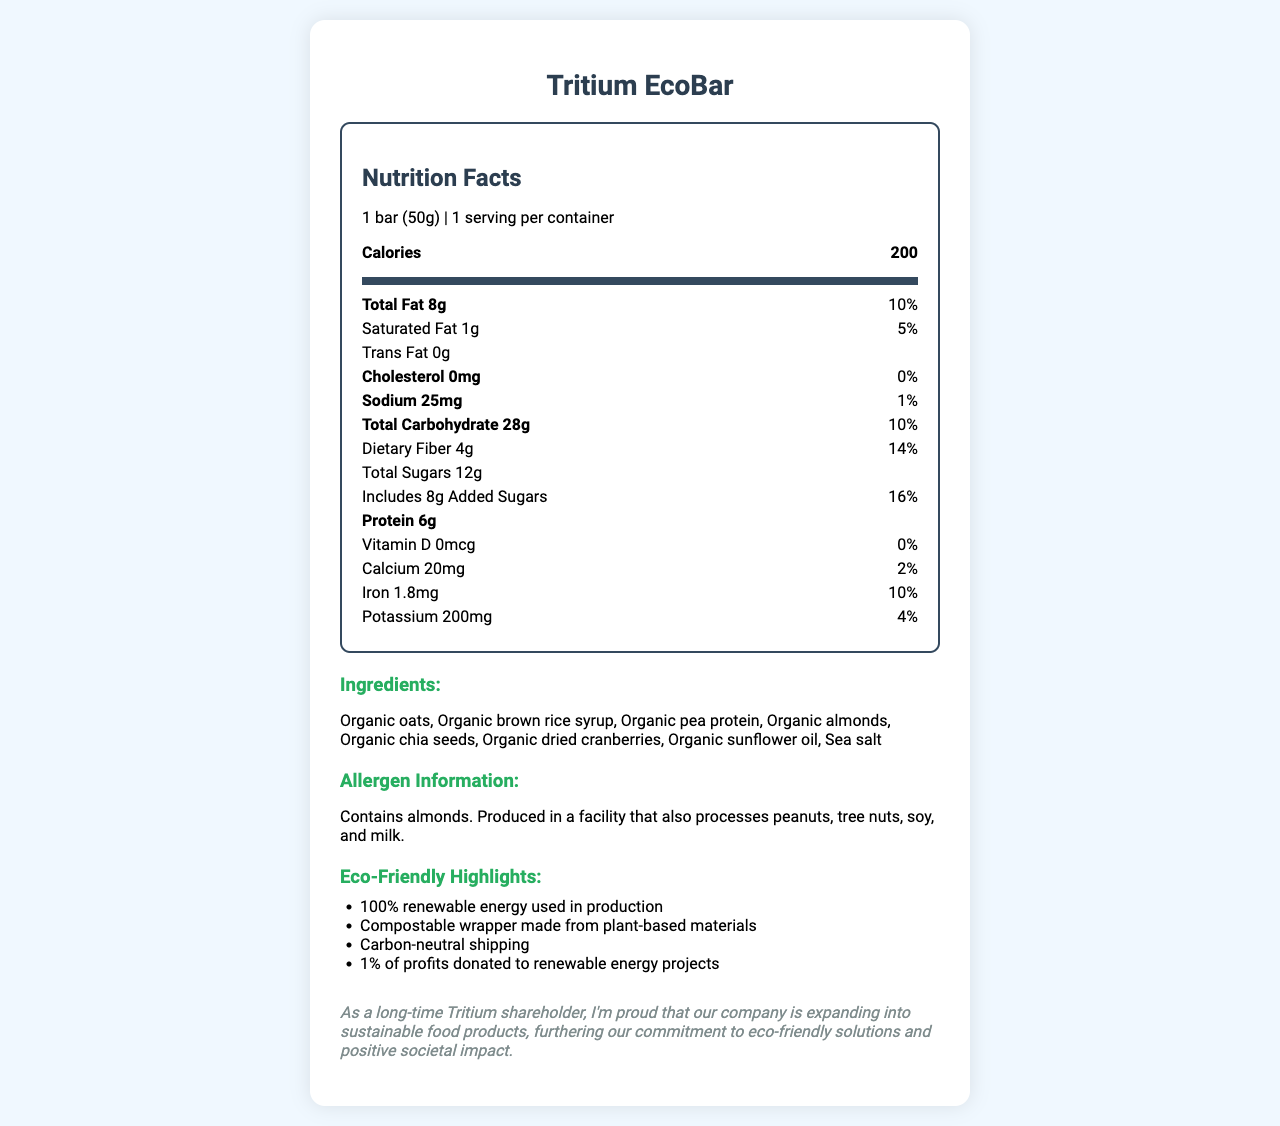what is the serving size? The serving size is mentioned near the top of the nutrition facts: "1 bar (50g)."
Answer: 1 bar (50g) how much dietary fiber does a Tritium EcoBar contain? The amount of dietary fiber is listed under "Total Carbohydrate": "Dietary Fiber 4g."
Answer: 4g how many calories are in one Tritium EcoBar? The number of calories is prominently displayed under "Calories": "200."
Answer: 200 which ingredient is not organic? The list of ingredients includes many organic items, but "Sea salt" does not have the "organic" label.
Answer: Sea salt what percentage of the daily value for iron does one bar provide? Under the iron nutrient information, it states: "Iron 1.8mg 10%."
Answer: 10% what are the eco-friendly highlights associated with the Tritium EcoBar? These points are all listed under the "Eco-Friendly Highlights" section of the document.
Answer: 100% renewable energy used in production, Compostable wrapper made from plant-based materials, Carbon-neutral shipping, 1% of profits donated to renewable energy projects how much protein is in a Tritium EcoBar? The amount of protein is listed in the nutrition facts: "Protein 6g."
Answer: 6g does a Tritium EcoBar contain any trans fat? The document specifically states "Trans Fat 0g."
Answer: No what allergens is the Tritium EcoBar produced near? A. Peanuts B. Tree nuts C. Soy D. Milk E. All of the above The allergen information notes that it is produced in a facility that processes: "peanuts, tree nuts, soy, and milk."
Answer: E how much added sugar is in one bar? A. 4g B. 8g C. 10g D. 12g Under sugars, it states: "Includes 8g Added Sugars."
Answer: B is the wrapper of the Tritium EcoBar compostable? The eco-friendly highlights include "Compostable wrapper made from plant-based materials."
Answer: Yes how is Tritium contributing to renewable energy projects? This is stated in the eco-friendly highlights: "1% of profits donated to renewable energy projects."
Answer: 1% of profits donated to renewable energy projects what is the main message of the document? The document includes the nutrition facts, a list of ingredients, allergen information, eco-friendly highlights, and a shareholder note emphasizing Tritium's commitment to positive societal impact through sustainable food products.
Answer: The main message of the document is to provide detailed nutritional information about the Tritium EcoBar, highlighting its eco-friendly attributes and the company's dedication to sustainable practices. what is the source of pea protein? The document lists "Organic pea protein" as an ingredient, but does not detail the specific source or supplier.
Answer: Cannot be determined 